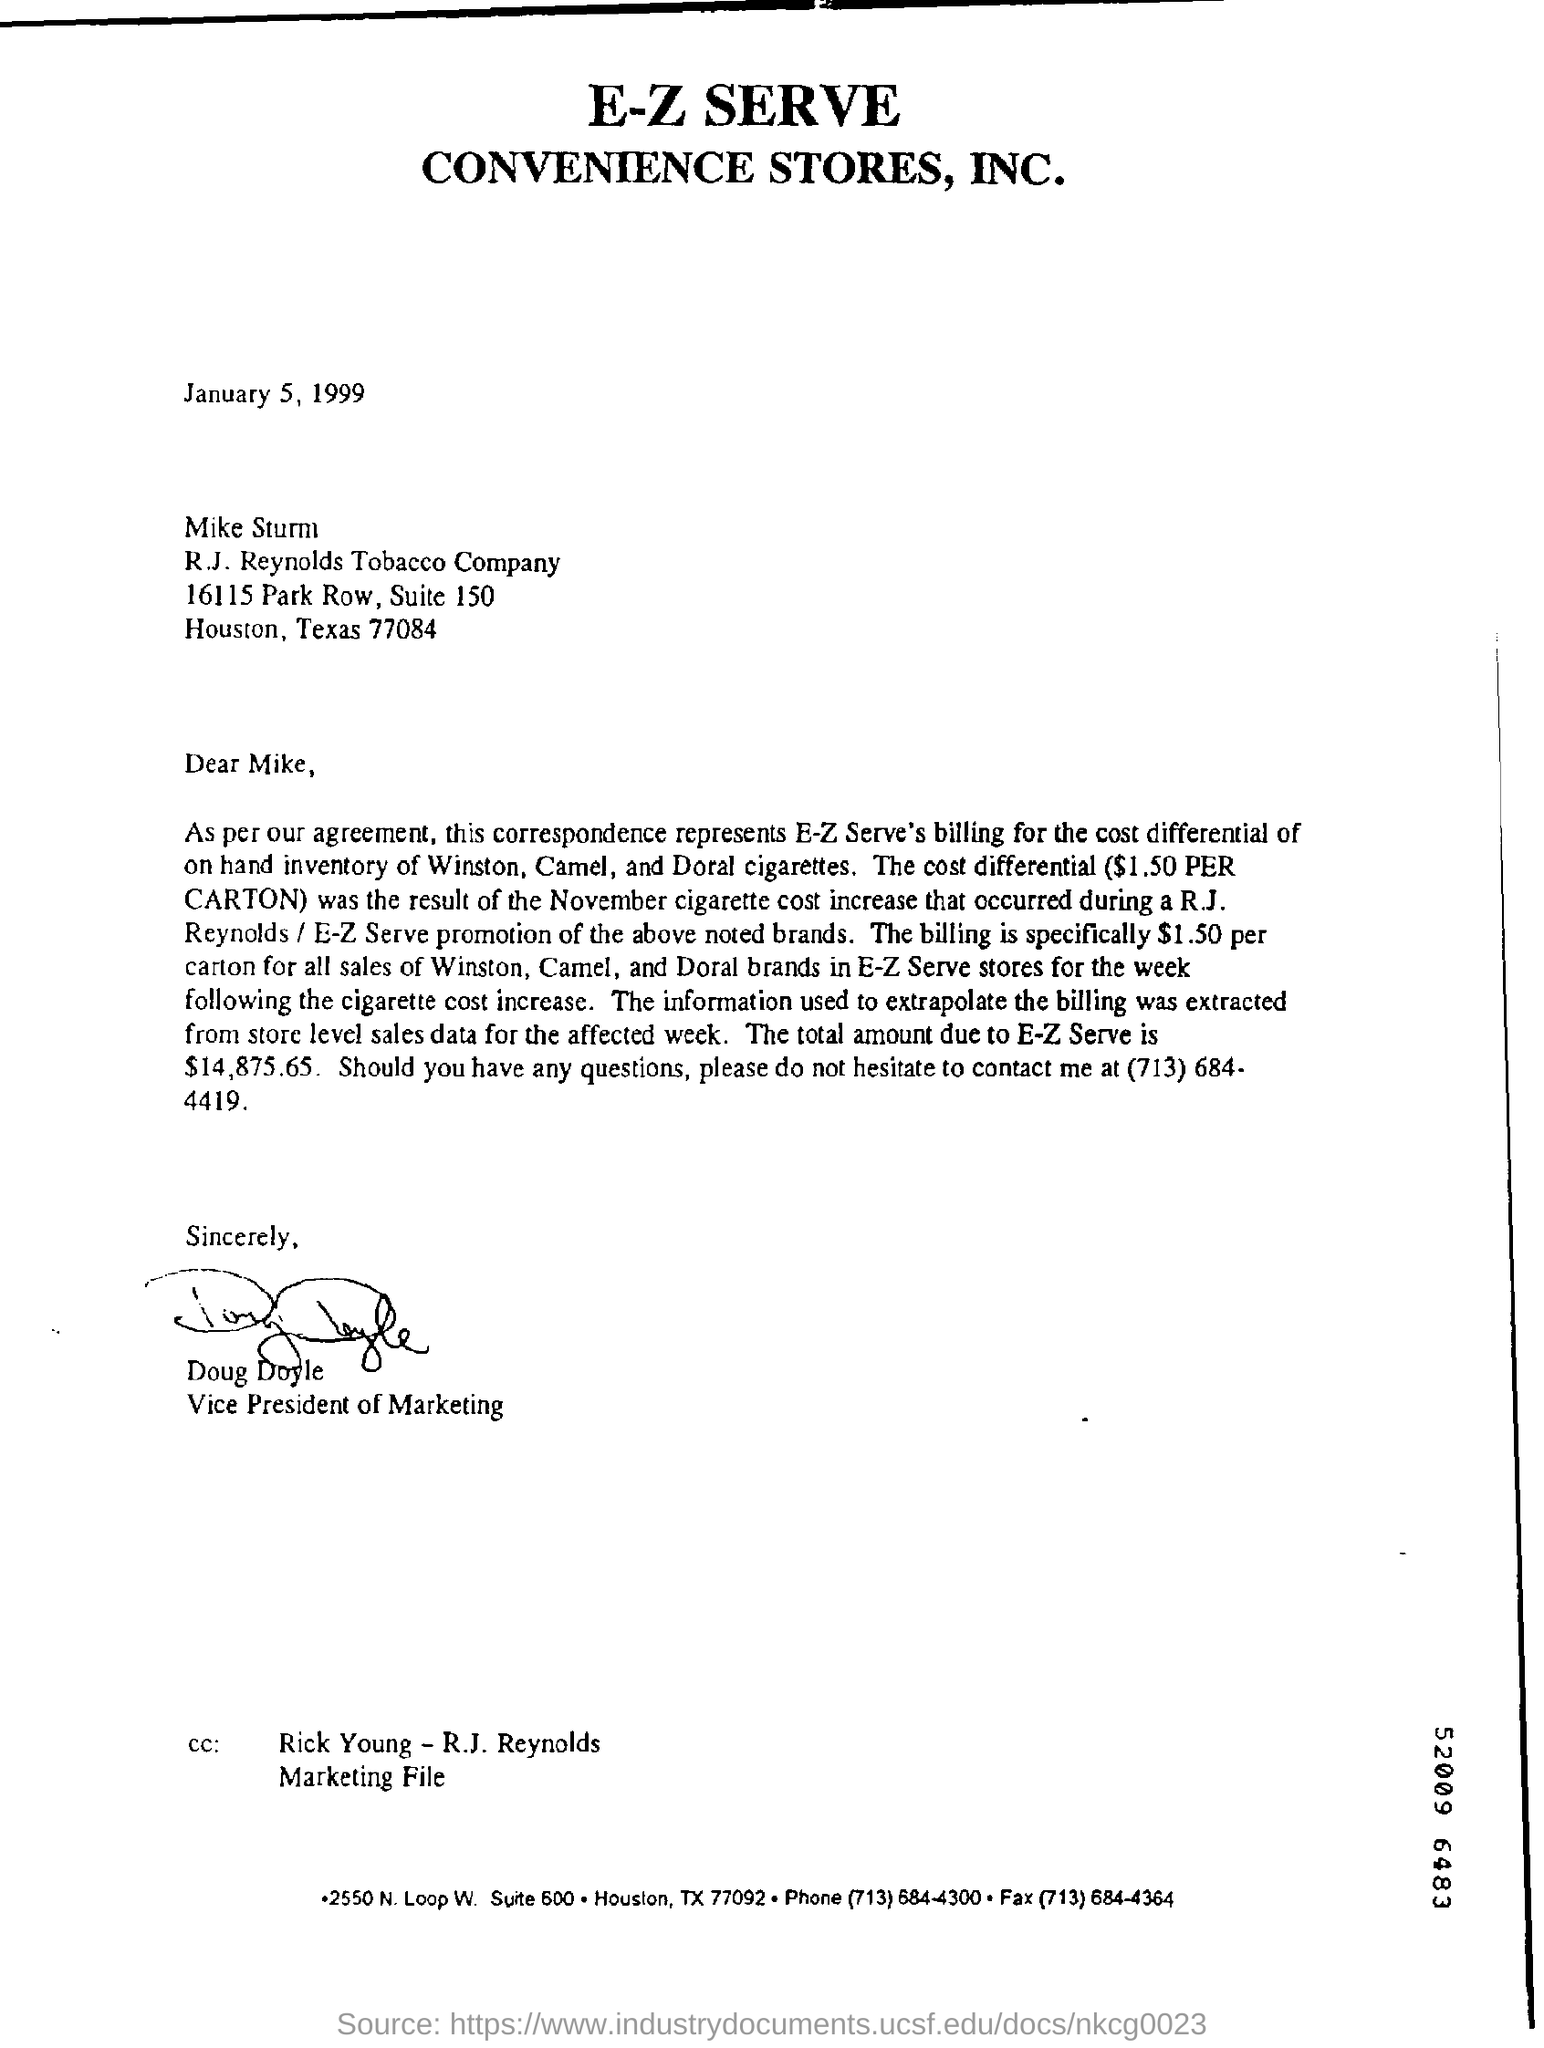To whom this letter is written ?
Your answer should be compact. Mike sturm. This letter was written by whom ?
Give a very brief answer. Doug Doyle. 